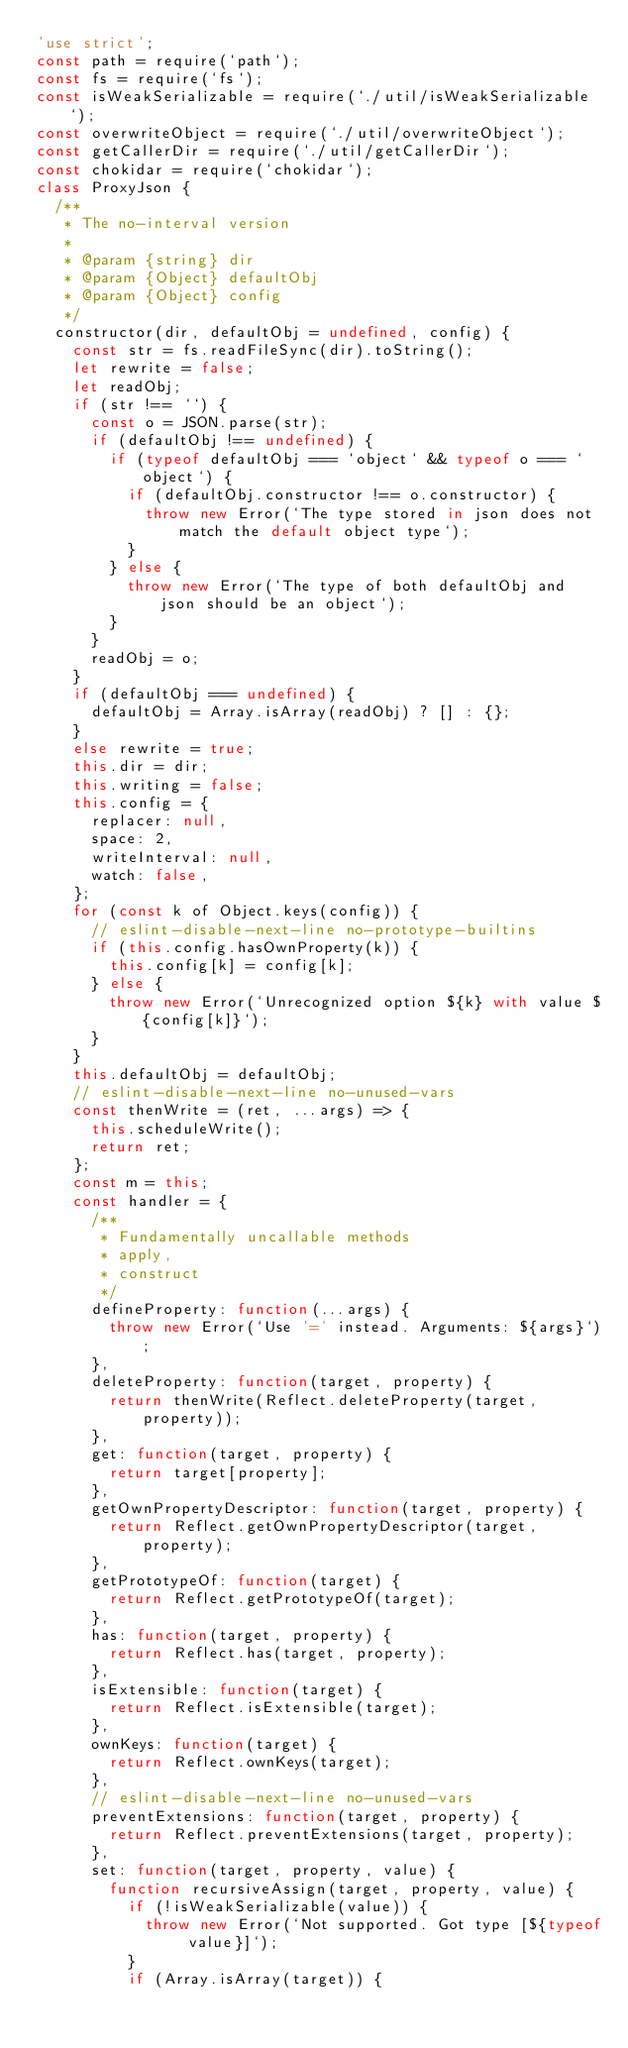<code> <loc_0><loc_0><loc_500><loc_500><_JavaScript_>'use strict';
const path = require(`path`);
const fs = require(`fs`);
const isWeakSerializable = require(`./util/isWeakSerializable`);
const overwriteObject = require(`./util/overwriteObject`);
const getCallerDir = require(`./util/getCallerDir`);
const chokidar = require(`chokidar`);
class ProxyJson {
  /**
   * The no-interval version
   *
   * @param {string} dir
   * @param {Object} defaultObj
   * @param {Object} config
   */
  constructor(dir, defaultObj = undefined, config) {
    const str = fs.readFileSync(dir).toString();
    let rewrite = false;
    let readObj;
    if (str !== ``) {
      const o = JSON.parse(str);
      if (defaultObj !== undefined) {
        if (typeof defaultObj === `object` && typeof o === `object`) {
          if (defaultObj.constructor !== o.constructor) {
            throw new Error(`The type stored in json does not match the default object type`);
          }
        } else {
          throw new Error(`The type of both defaultObj and json should be an object`);
        }
      }
      readObj = o;
    }
    if (defaultObj === undefined) {
      defaultObj = Array.isArray(readObj) ? [] : {};
    }
    else rewrite = true;
    this.dir = dir;
    this.writing = false;
    this.config = {
      replacer: null,
      space: 2,
      writeInterval: null,
      watch: false,
    };
    for (const k of Object.keys(config)) {
      // eslint-disable-next-line no-prototype-builtins
      if (this.config.hasOwnProperty(k)) {
        this.config[k] = config[k];
      } else {
        throw new Error(`Unrecognized option ${k} with value ${config[k]}`);
      }
    }
    this.defaultObj = defaultObj;
    // eslint-disable-next-line no-unused-vars
    const thenWrite = (ret, ...args) => {
      this.scheduleWrite();
      return ret;
    };
    const m = this;
    const handler = {
      /**
       * Fundamentally uncallable methods
       * apply,
       * construct
       */
      defineProperty: function(...args) {
        throw new Error(`Use '=' instead. Arguments: ${args}`);
      },
      deleteProperty: function(target, property) {
        return thenWrite(Reflect.deleteProperty(target, property));
      },
      get: function(target, property) {
        return target[property];
      },
      getOwnPropertyDescriptor: function(target, property) {
        return Reflect.getOwnPropertyDescriptor(target, property);
      },
      getPrototypeOf: function(target) {
        return Reflect.getPrototypeOf(target);
      },
      has: function(target, property) {
        return Reflect.has(target, property);
      },
      isExtensible: function(target) {
        return Reflect.isExtensible(target);
      },
      ownKeys: function(target) {
        return Reflect.ownKeys(target);
      },
      // eslint-disable-next-line no-unused-vars
      preventExtensions: function(target, property) {
        return Reflect.preventExtensions(target, property);
      },
      set: function(target, property, value) {
        function recursiveAssign(target, property, value) {
          if (!isWeakSerializable(value)) {
            throw new Error(`Not supported. Got type [${typeof value}]`);
          }
          if (Array.isArray(target)) {</code> 